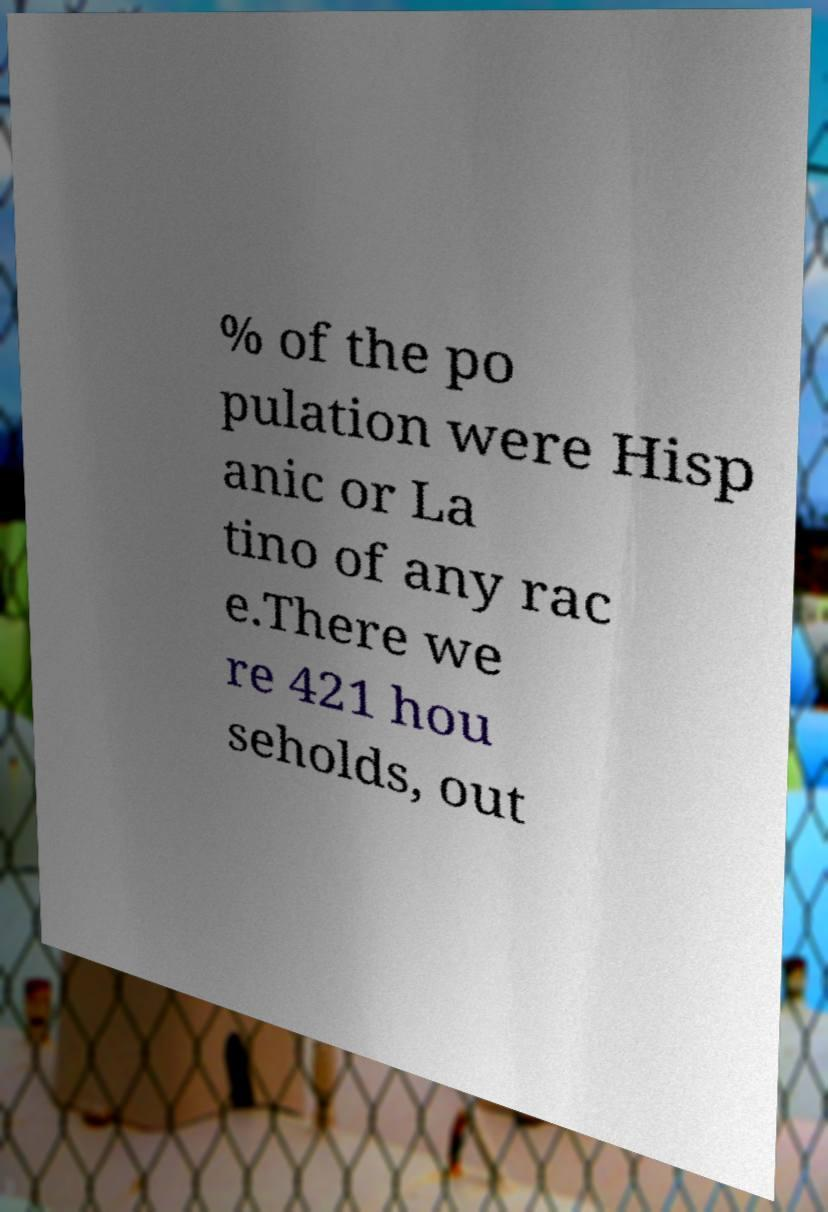There's text embedded in this image that I need extracted. Can you transcribe it verbatim? % of the po pulation were Hisp anic or La tino of any rac e.There we re 421 hou seholds, out 